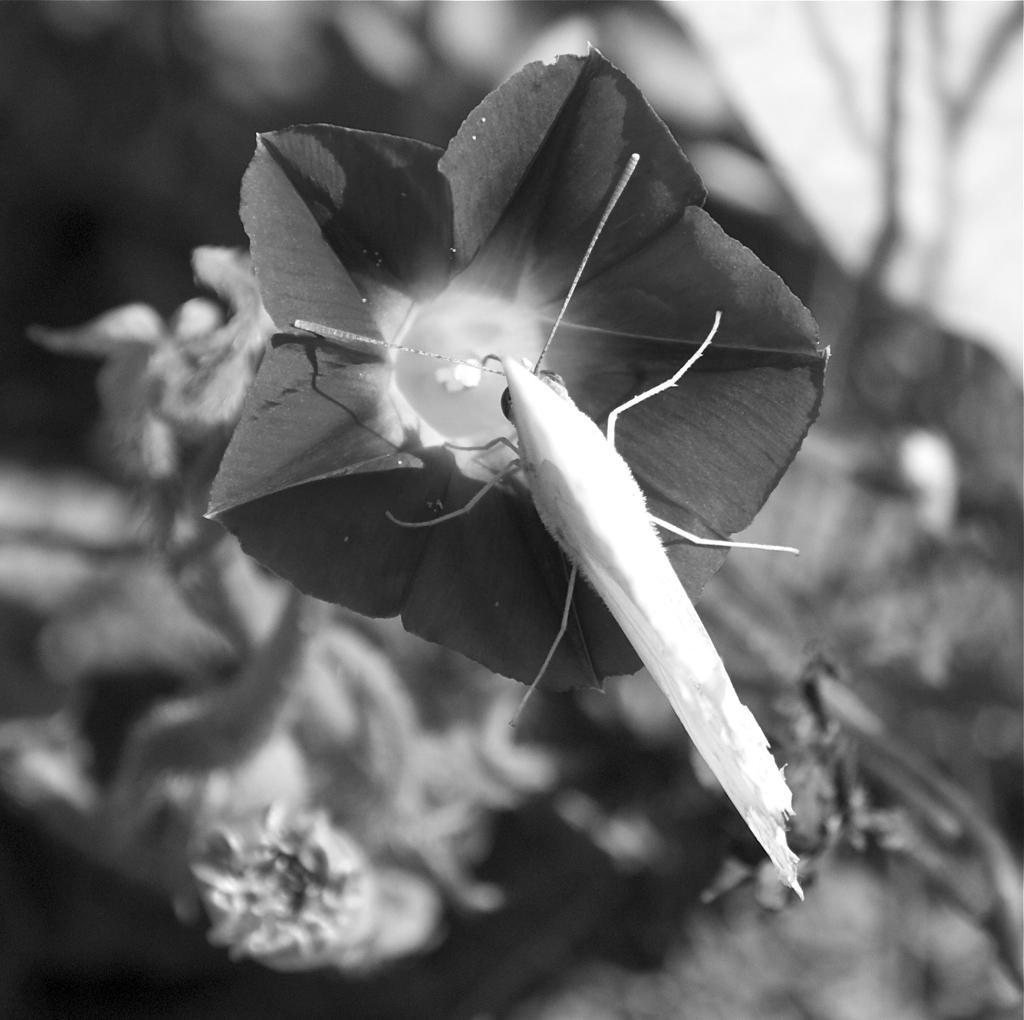Please provide a concise description of this image. In this black and white image, we can see an insect on the flower. In the background, image is blurred. 